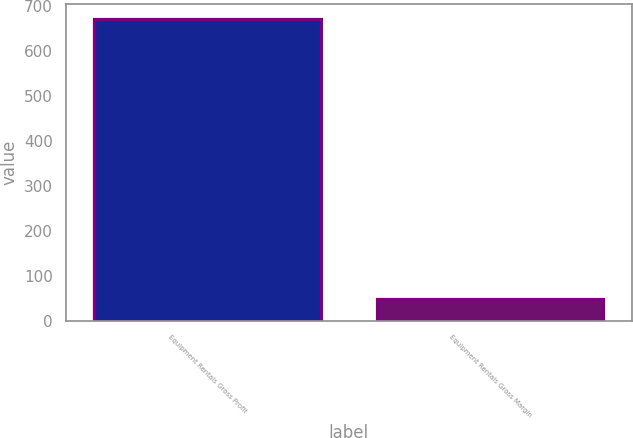Convert chart. <chart><loc_0><loc_0><loc_500><loc_500><bar_chart><fcel>Equipment Rentals Gross Profit<fcel>Equipment Rentals Gross Margin<nl><fcel>670<fcel>48.2<nl></chart> 